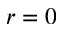Convert formula to latex. <formula><loc_0><loc_0><loc_500><loc_500>r = 0</formula> 